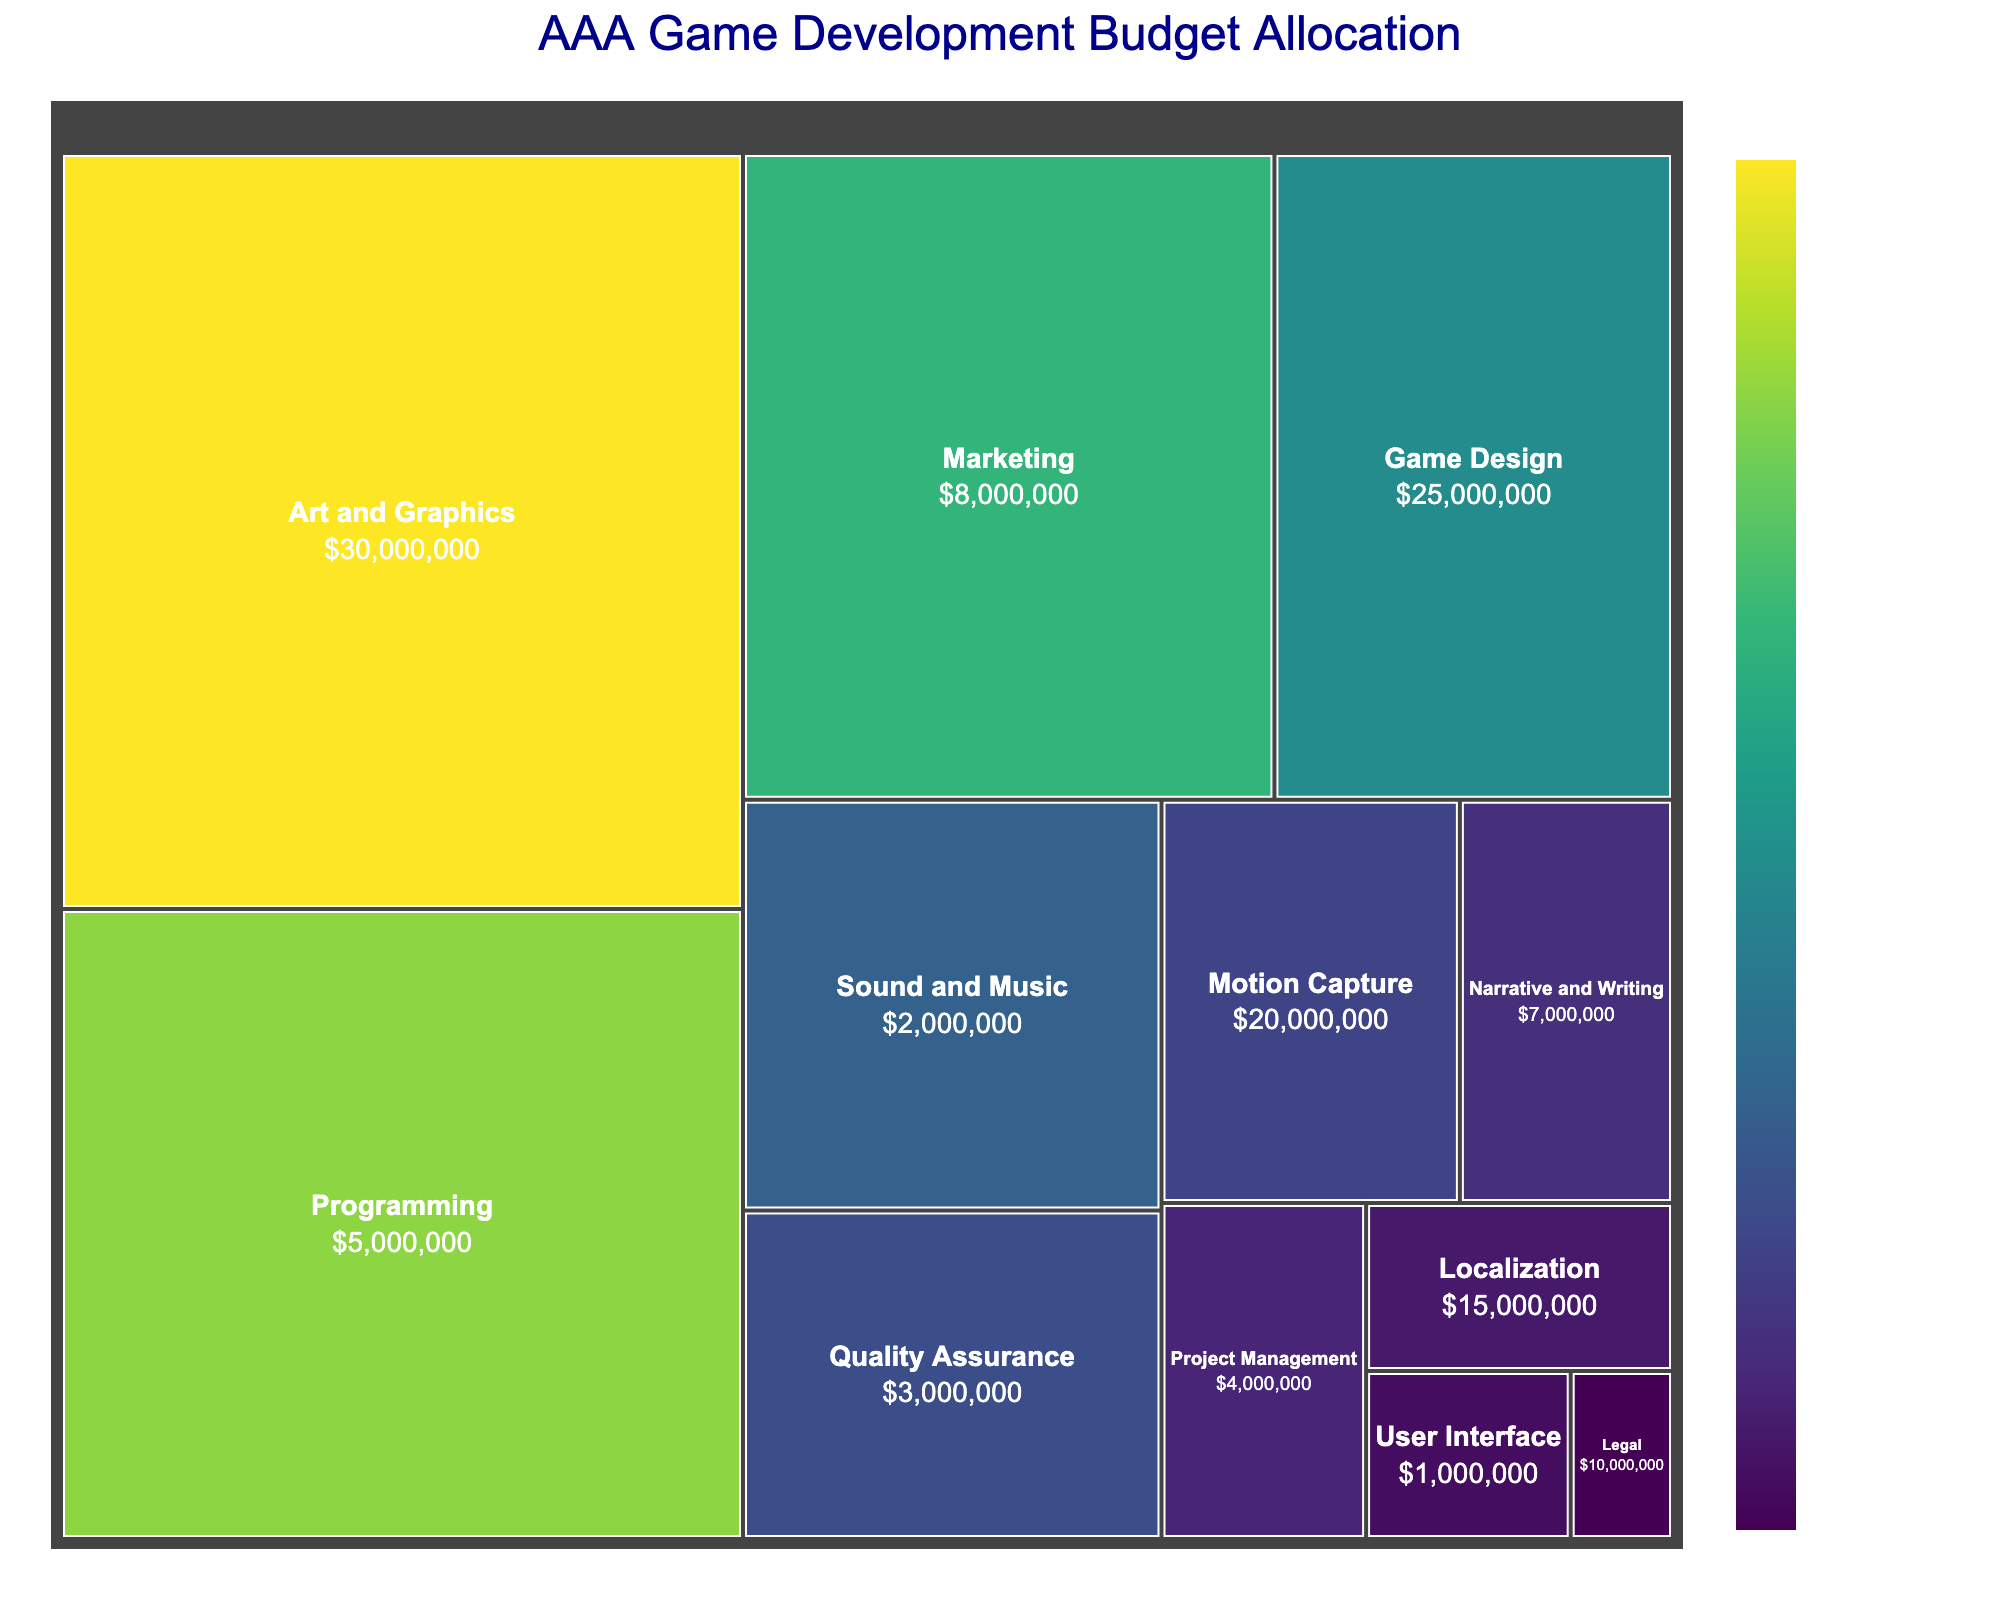What's the title of the treemap? The title is prominently positioned at the top center of the treemap. "AAA Game Development Budget Allocation" is specified as the title in the given plot generation code and set to display in dark blue color in a large font.
Answer: AAA Game Development Budget Allocation Which department has the highest budget allocation? To find the department with the highest allocation, look for the largest segment and the department label associated with it. The "Art and Graphics" department has the highest allocation, visible by its large square area.
Answer: Art and Graphics How does the budget for Programming compare to that of Game Design? Compare the areas labeled "Programming" and "Game Design" in the treemap. Programming has an allocation of $25,000,000, which is greater than the $15,000,000 allocated for Game Design by $10,000,000.
Answer: Programming has $10,000,000 more than Game Design What is the combined budget for Quality Assurance and User Interface? Sum the allocations of Quality Assurance and User Interface. Quality Assurance has $8,000,000 and User Interface has $2,000,000. Combined, they total $10,000,000.
Answer: $10,000,000 Which department has the smallest budget allocation? Look for the smallest labeled area in the treemap, indicating the lowest budget allocation. The "Legal" department, with a $1,000,000 allocation, is the smallest.
Answer: Legal What's the difference between the budgets for Marketing and Sound and Music? Observe the budget labels for both departments. Marketing has a $20,000,000 allocation while Sound and Music has $10,000,000. The difference is $10,000,000.
Answer: $10,000,000 How many departments have a budget allocation greater than $10,000,000? Count the departments where the labeled budget is more than $10,000,000. The departments are: Art and Graphics, Programming, Game Design, and Marketing. There are four such departments.
Answer: 4 What percentage of the total budget is allocated to Motion Capture? To find this, divide the Motion Capture budget ($7,000,000) by the sum of all budgets and multiply by 100. The total is $150,000,000. (7,000,000/150,000,000) * 100 = 4.67%.
Answer: 4.67% How does the budget for Narrative and Writing compare to Project Management? Compare the labeled areas for both departments. Narrative and Writing has $5,000,000 and Project Management has $4,000,000. Narrative and Writing has $1,000,000 more.
Answer: $1,000,000 more for Narrative and Writing What is the average budget allocated per department? To find the average, sum all department budgets and divide by the number of departments (12). The total budget is $150,000,000. So, $150,000,000 / 12 = $12,500,000.
Answer: $12,500,000 